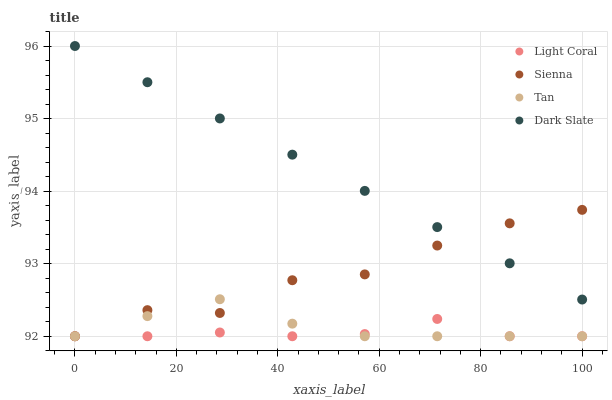Does Light Coral have the minimum area under the curve?
Answer yes or no. Yes. Does Dark Slate have the maximum area under the curve?
Answer yes or no. Yes. Does Sienna have the minimum area under the curve?
Answer yes or no. No. Does Sienna have the maximum area under the curve?
Answer yes or no. No. Is Dark Slate the smoothest?
Answer yes or no. Yes. Is Sienna the roughest?
Answer yes or no. Yes. Is Tan the smoothest?
Answer yes or no. No. Is Tan the roughest?
Answer yes or no. No. Does Light Coral have the lowest value?
Answer yes or no. Yes. Does Dark Slate have the lowest value?
Answer yes or no. No. Does Dark Slate have the highest value?
Answer yes or no. Yes. Does Sienna have the highest value?
Answer yes or no. No. Is Light Coral less than Dark Slate?
Answer yes or no. Yes. Is Dark Slate greater than Tan?
Answer yes or no. Yes. Does Tan intersect Sienna?
Answer yes or no. Yes. Is Tan less than Sienna?
Answer yes or no. No. Is Tan greater than Sienna?
Answer yes or no. No. Does Light Coral intersect Dark Slate?
Answer yes or no. No. 